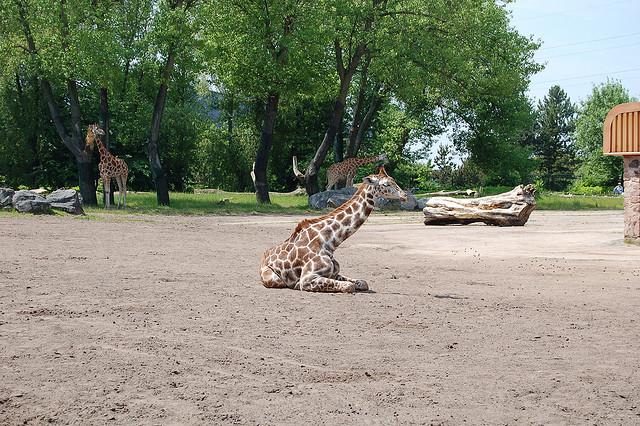Is the giraffe sleeping?
Give a very brief answer. No. What is sitting down in the sun?
Concise answer only. Giraffe. What animal is in this picture?
Short answer required. Giraffe. Can the giraffe walk?
Give a very brief answer. Yes. Where is the giraffe that is standing?
Give a very brief answer. By trees. Are the animals in the desert?
Answer briefly. No. Why is there dirt by the giraffes?
Write a very short answer. Desert. 